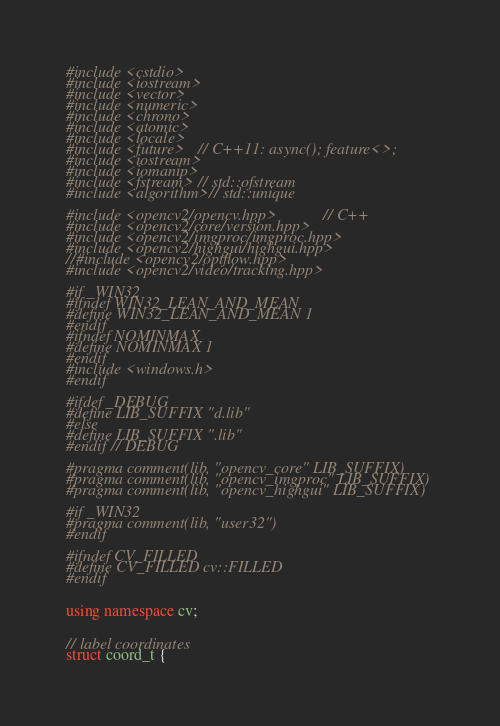Convert code to text. <code><loc_0><loc_0><loc_500><loc_500><_C++_>#include <cstdio>
#include <iostream>
#include <vector>
#include <numeric>
#include <chrono>
#include <atomic>
#include <locale>
#include <future>	// C++11: async(); feature<>;
#include <iostream>
#include <iomanip>
#include <fstream>  // std::ofstream
#include <algorithm> // std::unique

#include <opencv2/opencv.hpp>			// C++
#include <opencv2/core/version.hpp>
#include <opencv2/imgproc/imgproc.hpp>
#include <opencv2/highgui/highgui.hpp>
//#include <opencv2/optflow.hpp>
#include <opencv2/video/tracking.hpp>

#if _WIN32
#ifndef WIN32_LEAN_AND_MEAN
#define WIN32_LEAN_AND_MEAN 1
#endif
#ifndef NOMINMAX
#define NOMINMAX 1
#endif
#include <windows.h>
#endif

#ifdef _DEBUG
#define LIB_SUFFIX "d.lib"
#else
#define LIB_SUFFIX ".lib"
#endif // DEBUG

#pragma comment(lib, "opencv_core" LIB_SUFFIX)
#pragma comment(lib, "opencv_imgproc" LIB_SUFFIX)
#pragma comment(lib, "opencv_highgui" LIB_SUFFIX)

#if _WIN32
#pragma comment(lib, "user32")
#endif

#ifndef CV_FILLED
#define CV_FILLED cv::FILLED
#endif


using namespace cv;


// label coordinates
struct coord_t {</code> 